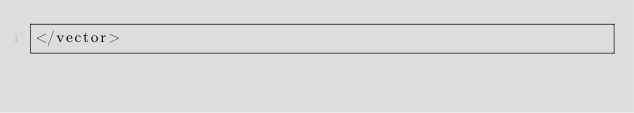<code> <loc_0><loc_0><loc_500><loc_500><_XML_></vector>
</code> 